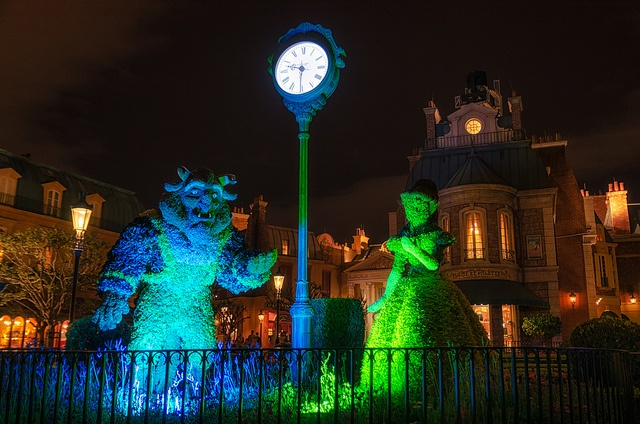Describe the objects in this image and their specific colors. I can see a clock in black, white, darkgray, lavender, and gray tones in this image. 